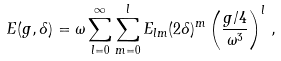Convert formula to latex. <formula><loc_0><loc_0><loc_500><loc_500>E ( g , \delta ) = \omega \sum _ { l = 0 } ^ { \infty } \sum _ { m = 0 } ^ { l } E _ { l m } ( 2 \delta ) ^ { m } \left ( \frac { g / 4 } { \omega ^ { 3 } } \right ) ^ { l } \, ,</formula> 